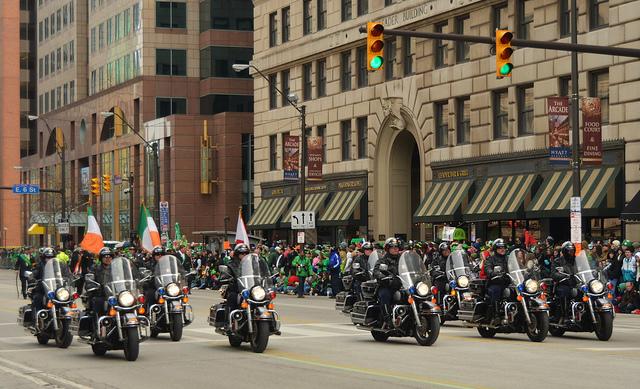What color is the stop light?
Short answer required. Green. Are there any women riding motorcycles?
Be succinct. No. What kind of parade is this?
Short answer required. Police. Is the light red?
Write a very short answer. No. How many motorcycles on the street?
Write a very short answer. 9. 